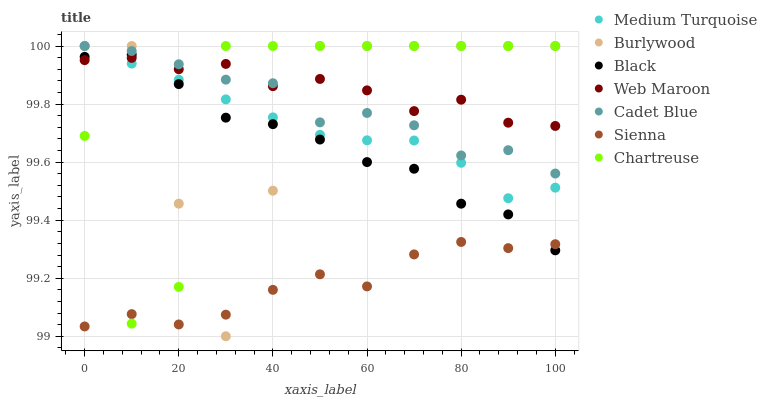Does Sienna have the minimum area under the curve?
Answer yes or no. Yes. Does Web Maroon have the maximum area under the curve?
Answer yes or no. Yes. Does Burlywood have the minimum area under the curve?
Answer yes or no. No. Does Burlywood have the maximum area under the curve?
Answer yes or no. No. Is Medium Turquoise the smoothest?
Answer yes or no. Yes. Is Chartreuse the roughest?
Answer yes or no. Yes. Is Burlywood the smoothest?
Answer yes or no. No. Is Burlywood the roughest?
Answer yes or no. No. Does Burlywood have the lowest value?
Answer yes or no. Yes. Does Web Maroon have the lowest value?
Answer yes or no. No. Does Medium Turquoise have the highest value?
Answer yes or no. Yes. Does Web Maroon have the highest value?
Answer yes or no. No. Is Sienna less than Medium Turquoise?
Answer yes or no. Yes. Is Medium Turquoise greater than Sienna?
Answer yes or no. Yes. Does Burlywood intersect Black?
Answer yes or no. Yes. Is Burlywood less than Black?
Answer yes or no. No. Is Burlywood greater than Black?
Answer yes or no. No. Does Sienna intersect Medium Turquoise?
Answer yes or no. No. 